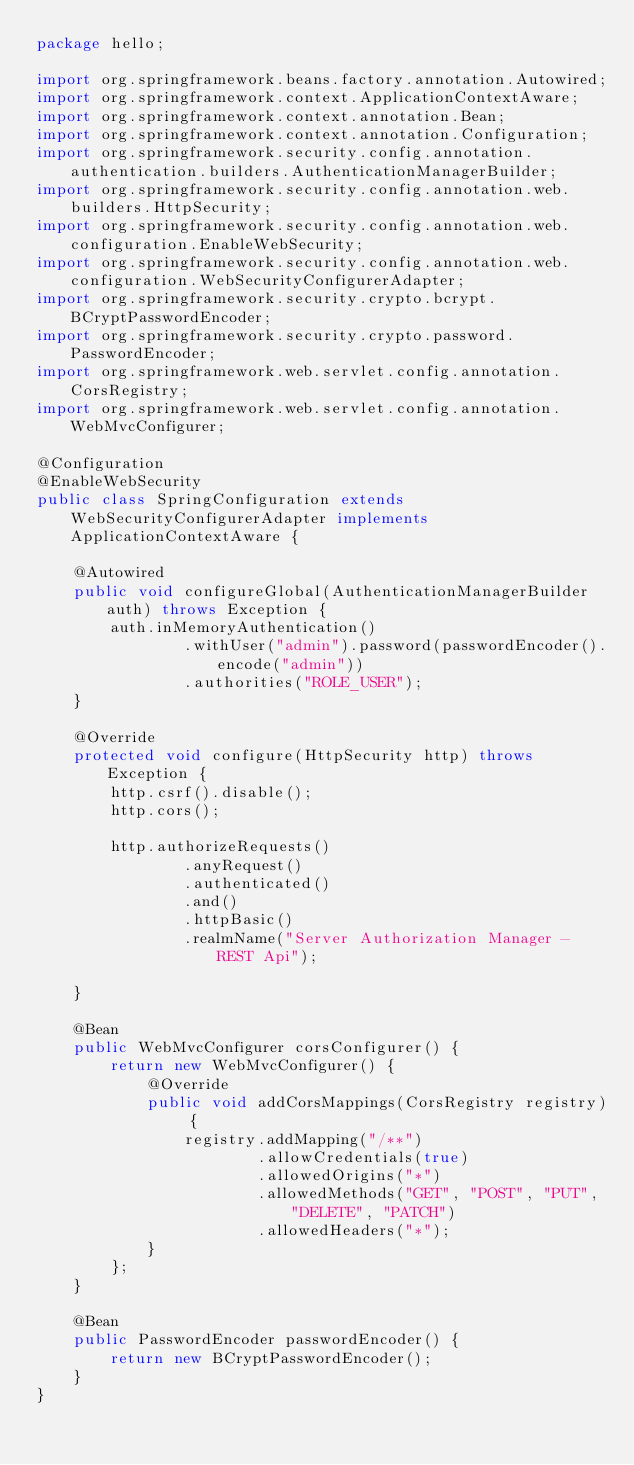<code> <loc_0><loc_0><loc_500><loc_500><_Java_>package hello;

import org.springframework.beans.factory.annotation.Autowired;
import org.springframework.context.ApplicationContextAware;
import org.springframework.context.annotation.Bean;
import org.springframework.context.annotation.Configuration;
import org.springframework.security.config.annotation.authentication.builders.AuthenticationManagerBuilder;
import org.springframework.security.config.annotation.web.builders.HttpSecurity;
import org.springframework.security.config.annotation.web.configuration.EnableWebSecurity;
import org.springframework.security.config.annotation.web.configuration.WebSecurityConfigurerAdapter;
import org.springframework.security.crypto.bcrypt.BCryptPasswordEncoder;
import org.springframework.security.crypto.password.PasswordEncoder;
import org.springframework.web.servlet.config.annotation.CorsRegistry;
import org.springframework.web.servlet.config.annotation.WebMvcConfigurer;

@Configuration
@EnableWebSecurity
public class SpringConfiguration extends WebSecurityConfigurerAdapter implements ApplicationContextAware {

    @Autowired
    public void configureGlobal(AuthenticationManagerBuilder auth) throws Exception {
        auth.inMemoryAuthentication()
                .withUser("admin").password(passwordEncoder().encode("admin"))
                .authorities("ROLE_USER");
    }

    @Override
    protected void configure(HttpSecurity http) throws Exception {
        http.csrf().disable();
        http.cors();

        http.authorizeRequests()
                .anyRequest()
                .authenticated()
                .and()
                .httpBasic()
                .realmName("Server Authorization Manager - REST Api");

    }

    @Bean
    public WebMvcConfigurer corsConfigurer() {
        return new WebMvcConfigurer() {
            @Override
            public void addCorsMappings(CorsRegistry registry) {
                registry.addMapping("/**")
                        .allowCredentials(true)
                        .allowedOrigins("*")
                        .allowedMethods("GET", "POST", "PUT", "DELETE", "PATCH")
                        .allowedHeaders("*");
            }
        };
    }

    @Bean
    public PasswordEncoder passwordEncoder() {
        return new BCryptPasswordEncoder();
    }
}
</code> 